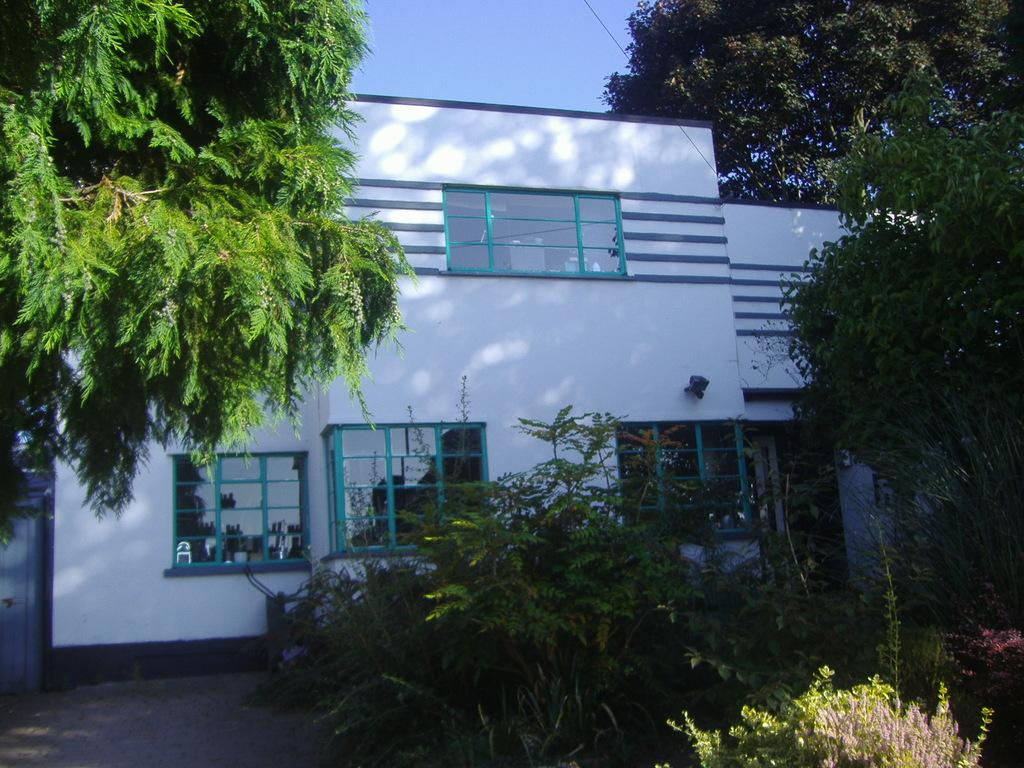What is the color of the building in the picture? The building in the picture is white. What feature can be seen on the building? The building has windows. What type of vegetation is present in the picture? There are trees and plants in the picture. What can be seen in the background of the picture? The sky is visible in the background of the picture. How many pickles are hanging from the trees in the picture? There are no pickles present in the picture; it features trees and plants. What is the temperature in the picture? The provided facts do not mention the temperature or heat in the picture. 